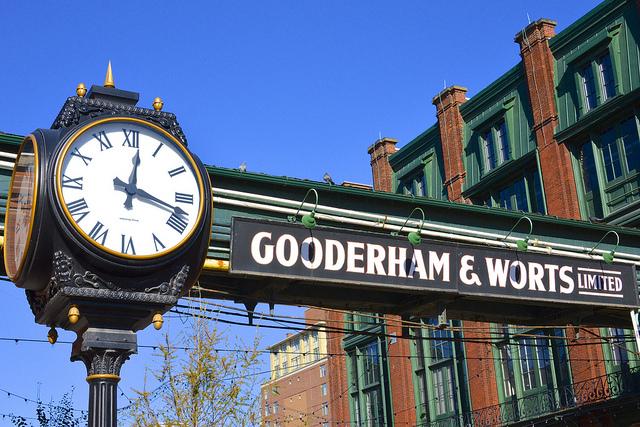What time is on the clock?
Concise answer only. 12:18. Is the building green and red?
Keep it brief. Yes. Do you see a sign?
Be succinct. Yes. 